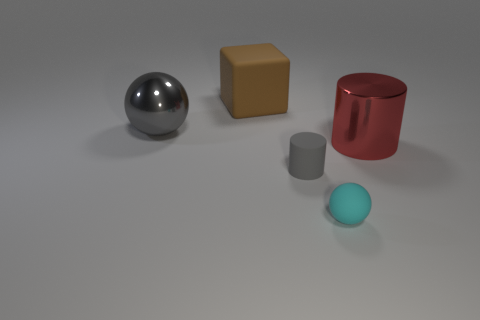Add 4 blocks. How many objects exist? 9 Subtract all balls. How many objects are left? 3 Add 5 blue matte cubes. How many blue matte cubes exist? 5 Subtract 1 cyan balls. How many objects are left? 4 Subtract all small gray cylinders. Subtract all red shiny things. How many objects are left? 3 Add 1 red objects. How many red objects are left? 2 